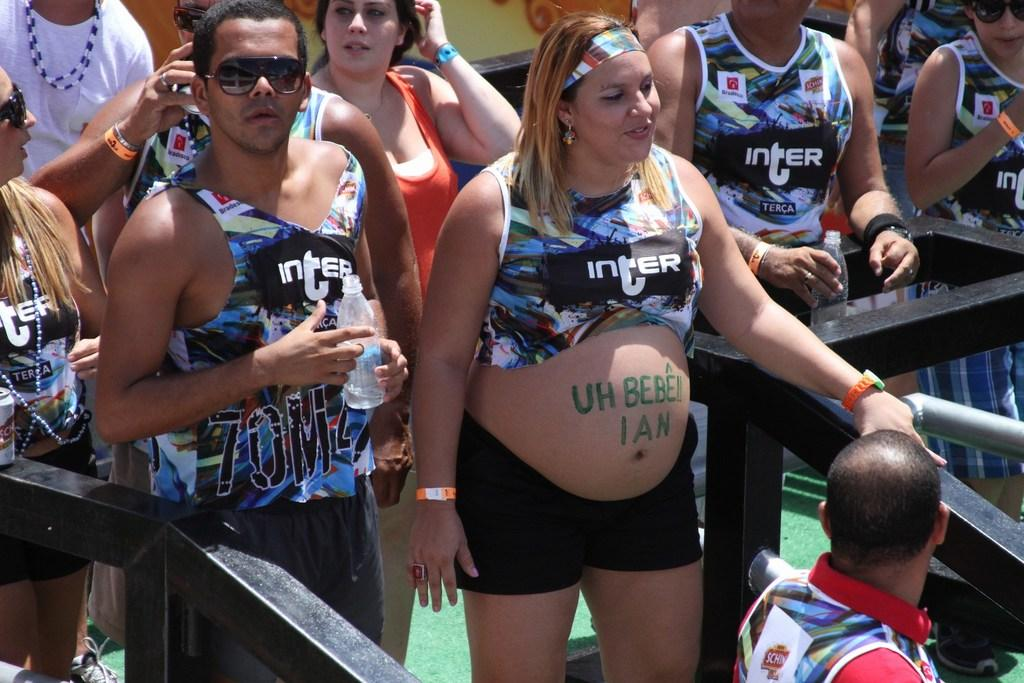<image>
Relay a brief, clear account of the picture shown. A group of people wearing Inter tanktops on a sunny day. 